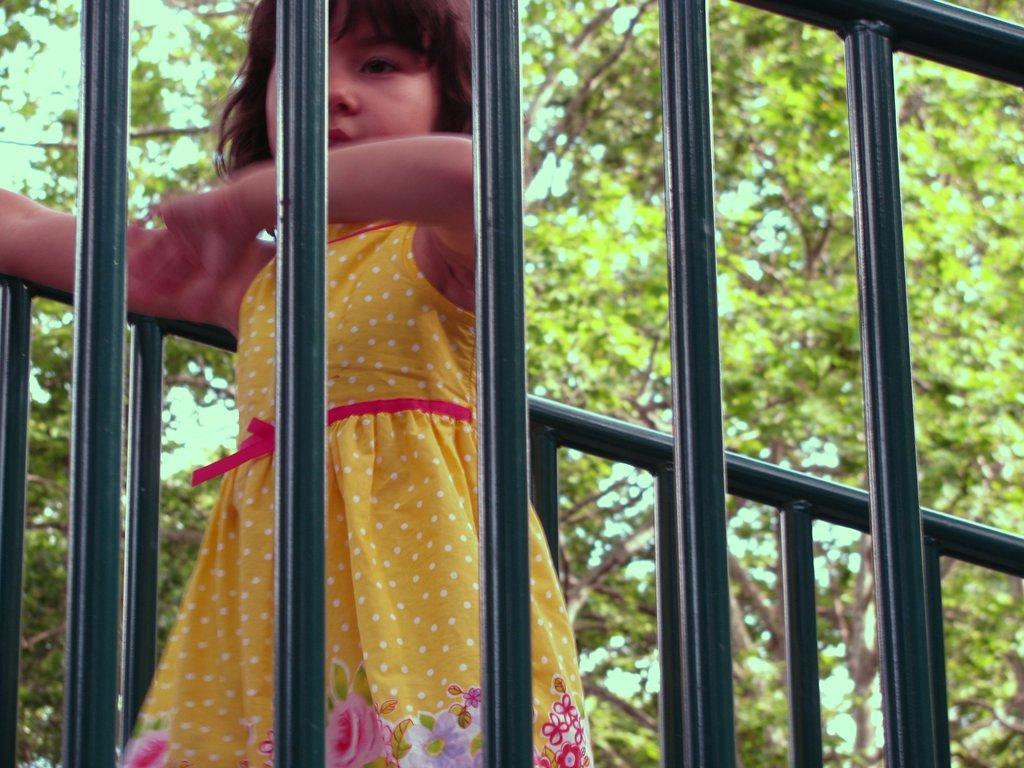In one or two sentences, can you explain what this image depicts? In this image I can see a girl is standing and I can see she is wearing yellow colour dress. On the both sides of her I can see railings and in the background I can see number of trees. 